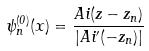Convert formula to latex. <formula><loc_0><loc_0><loc_500><loc_500>\psi _ { n } ^ { ( 0 ) } ( x ) = \frac { A i ( z - z _ { n } ) } { | A i ^ { \prime } ( - z _ { n } ) | }</formula> 